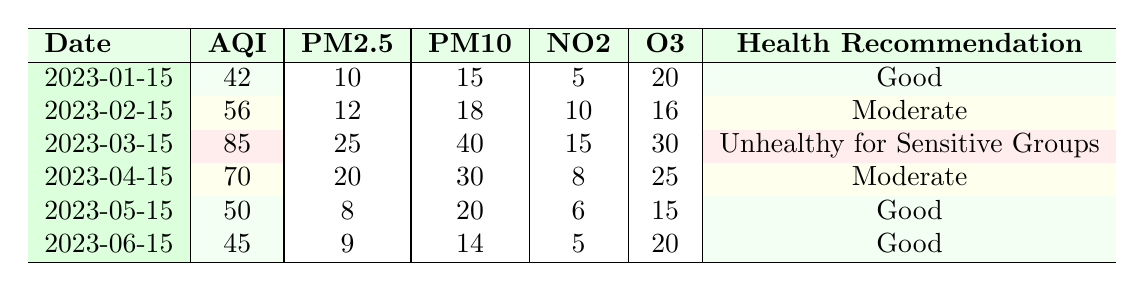What was the Air Quality Index (AQI) on March 15, 2023? Referring to the table, the AQI listed for March 15, 2023, is 85.
Answer: 85 What was the health recommendation on February 15, 2023? The table indicates that the health recommendation for that date is "Moderate."
Answer: Moderate What is the average PM2.5 level across all recorded dates? To find the average PM2.5, we add the PM2.5 values: 10 + 12 + 25 + 20 + 8 + 9 = 84. There are 6 data points, so the average PM2.5 is 84/6 = 14.
Answer: 14 Is the AQI ever classified as "Good"? By reviewing the table, the AQI is classified as "Good" on January 15, 2023, and again on May 15, 2023. Therefore, the answer is yes.
Answer: Yes What pollutant had the highest level recorded, and on what date? Looking through the pollutants listed, PM10 had the highest level of 40, recorded on March 15, 2023.
Answer: PM10 on March 15, 2023 What was the change in the AQI from January 15 to June 15? The AQI changed from 42 on January 15 to 45 on June 15. The change is calculated as 45 - 42 = 3.
Answer: 3 On which date was the air quality considered "Unhealthy for Sensitive Groups"? The table shows that on March 15, 2023, the air quality was labeled as "Unhealthy for Sensitive Groups."
Answer: March 15, 2023 What is the total of PM10 levels recorded from January to June? Summing the PM10 values gives: 15 + 18 + 40 + 30 + 20 + 14 = 137. Therefore, the total PM10 level across all dates is 137.
Answer: 137 Was there a date when the AQI was over 80? Looking at the table, only on March 15, 2023, was the AQI over 80, which was 85. Therefore, the answer is yes.
Answer: Yes 